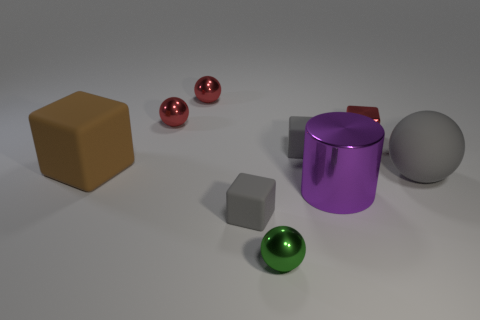How do the different shapes in the image contribute to its composition? The variety of shapes including spheres, a cylinder, and cubes, along with their placement, creates an interesting visual balance. The spheres add a sense of continuity and flow, the cubes provide structure, and the cylinder bridges the gap between the round and angular forms. 